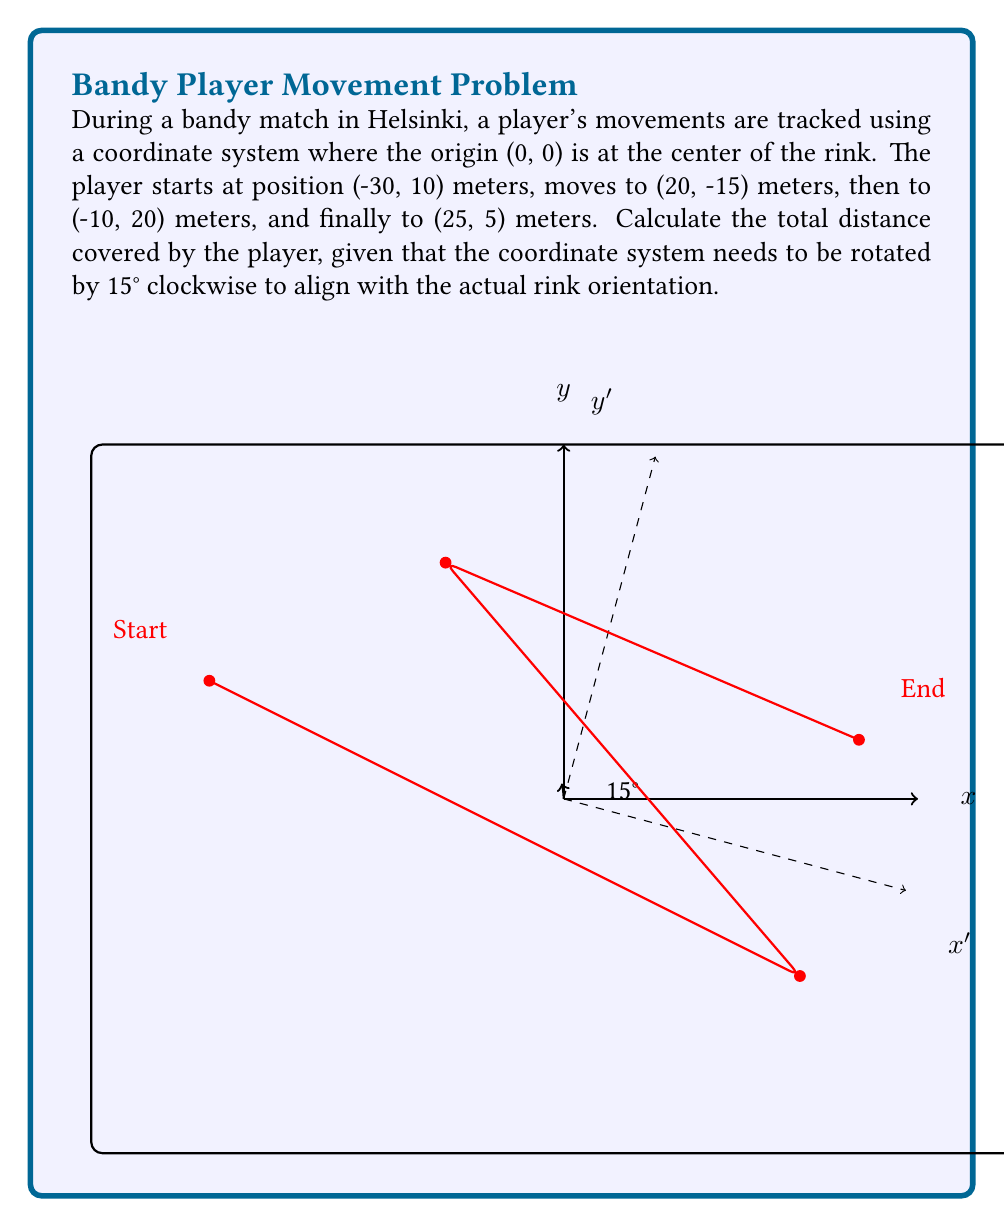Provide a solution to this math problem. To solve this problem, we need to follow these steps:

1) First, we need to apply the rotation transformation to all coordinates. The rotation matrix for a clockwise rotation by θ degrees is:

   $$R = \begin{bmatrix} \cos\theta & \sin\theta \\ -\sin\theta & \cos\theta \end{bmatrix}$$

   For θ = 15°, we have:

   $$R = \begin{bmatrix} \cos15° & \sin15° \\ -\sin15° & \cos15° \end{bmatrix} \approx \begin{bmatrix} 0.9659 & 0.2588 \\ -0.2588 & 0.9659 \end{bmatrix}$$

2) We apply this rotation to each point (x, y) using matrix multiplication:

   $$\begin{bmatrix} x' \\ y' \end{bmatrix} = \begin{bmatrix} 0.9659 & 0.2588 \\ -0.2588 & 0.9659 \end{bmatrix} \begin{bmatrix} x \\ y \end{bmatrix}$$

3) Let's transform each point:
   
   (-30, 10) → (-26.48, -15.98)
   (20, -15) → (23.91, -7.02)
   (-10, 20) → (-6.15, -21.24)
   (25, 5) → (25.27, -1.48)

4) Now we can calculate the distances between these transformed points using the distance formula:

   $$d = \sqrt{(x_2-x_1)^2 + (y_2-y_1)^2}$$

   Distance from (-26.48, -15.98) to (23.91, -7.02): 51.30 m
   Distance from (23.91, -7.02) to (-6.15, -21.24): 34.73 m
   Distance from (-6.15, -21.24) to (25.27, -1.48): 35.87 m

5) The total distance is the sum of these individual distances:

   51.30 + 34.73 + 35.87 = 121.90 meters
Answer: 121.90 meters 